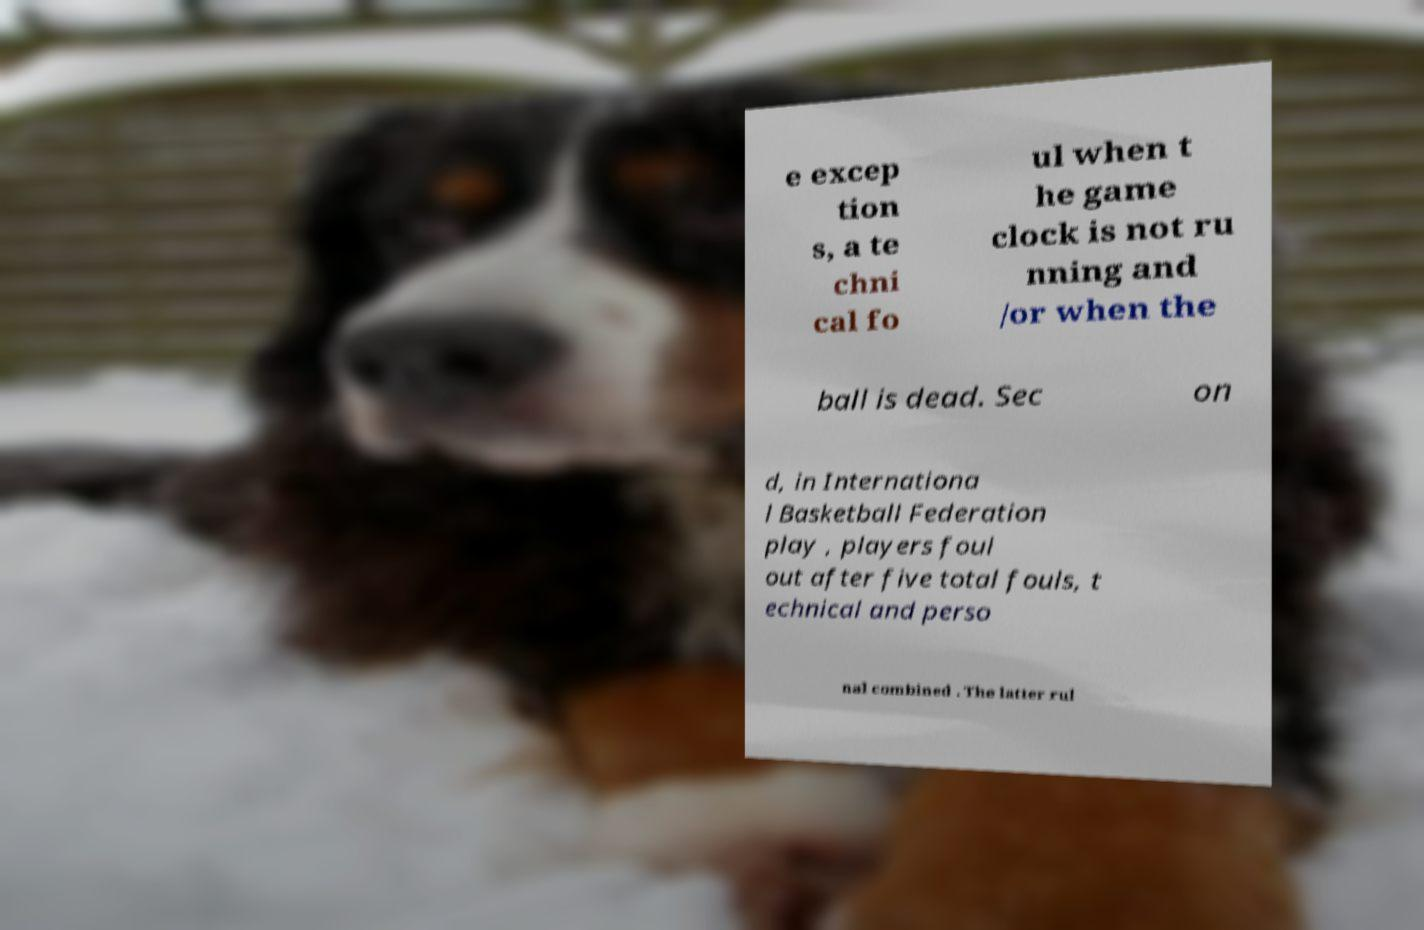For documentation purposes, I need the text within this image transcribed. Could you provide that? e excep tion s, a te chni cal fo ul when t he game clock is not ru nning and /or when the ball is dead. Sec on d, in Internationa l Basketball Federation play , players foul out after five total fouls, t echnical and perso nal combined . The latter rul 